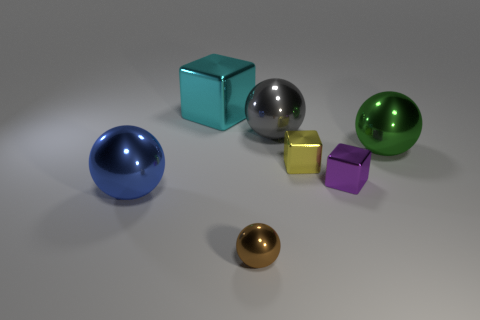What number of objects are big gray balls or blue shiny balls?
Give a very brief answer. 2. The yellow metal thing is what shape?
Ensure brevity in your answer.  Cube. There is a object that is in front of the big metallic thing that is in front of the green sphere; what is its shape?
Provide a short and direct response. Sphere. Do the big thing to the right of the small purple object and the brown object have the same material?
Your response must be concise. Yes. What number of yellow things are either tiny metal spheres or metal things?
Your answer should be compact. 1. Are there any metallic spheres that have the same color as the large cube?
Offer a terse response. No. Are there any small yellow blocks made of the same material as the cyan object?
Your answer should be very brief. Yes. The object that is in front of the tiny purple cube and right of the blue ball has what shape?
Ensure brevity in your answer.  Sphere. What number of large objects are purple things or gray metal things?
Give a very brief answer. 1. What number of other objects are there of the same shape as the large gray shiny object?
Make the answer very short. 3. 